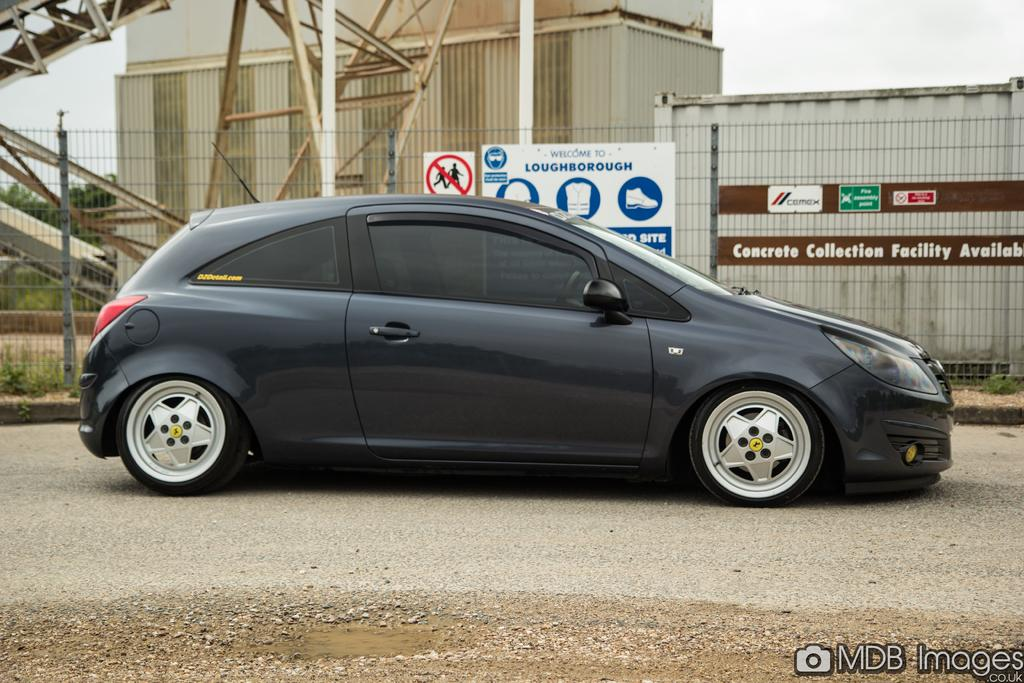What type of vehicle is in the image? There is a black car in the image. What is located at the bottom of the image? There is a road at the bottom of the image. What can be seen in the background of the image? There are buildings and a fencing in the background of the image. What is visible at the top of the image? The sky is visible at the top of the image. What type of education can be seen in the image? There is no reference to education in the image; it features a black car, a road, buildings, fencing, and the sky. What is the condition of the person's knee in the image? There is no person or knee visible in the image. 